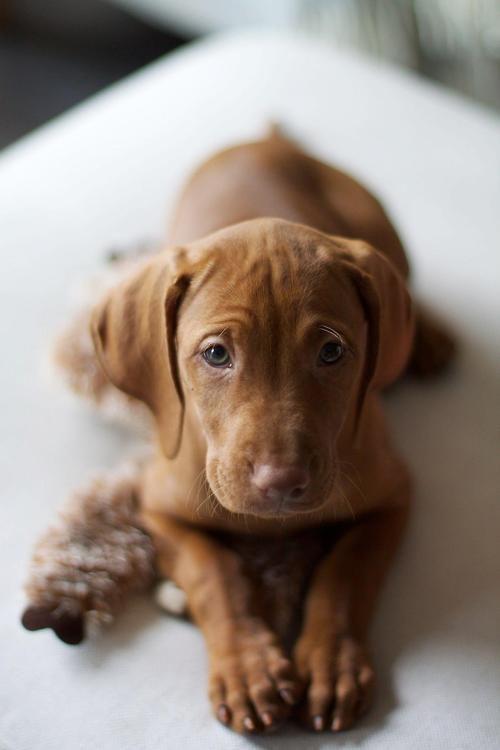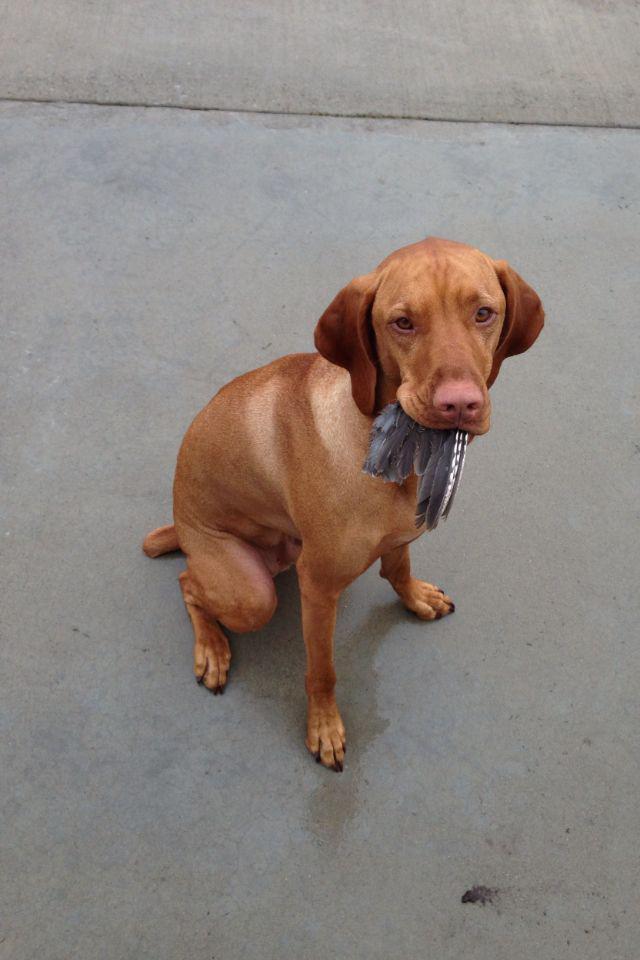The first image is the image on the left, the second image is the image on the right. Assess this claim about the two images: "There are three dogs.". Correct or not? Answer yes or no. No. The first image is the image on the left, the second image is the image on the right. Analyze the images presented: Is the assertion "Each image contains just one dog, and the left image features a young dog reclining with its head upright and front paws forward." valid? Answer yes or no. Yes. 